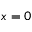Convert formula to latex. <formula><loc_0><loc_0><loc_500><loc_500>x = 0</formula> 